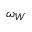Convert formula to latex. <formula><loc_0><loc_0><loc_500><loc_500>\omega _ { W }</formula> 